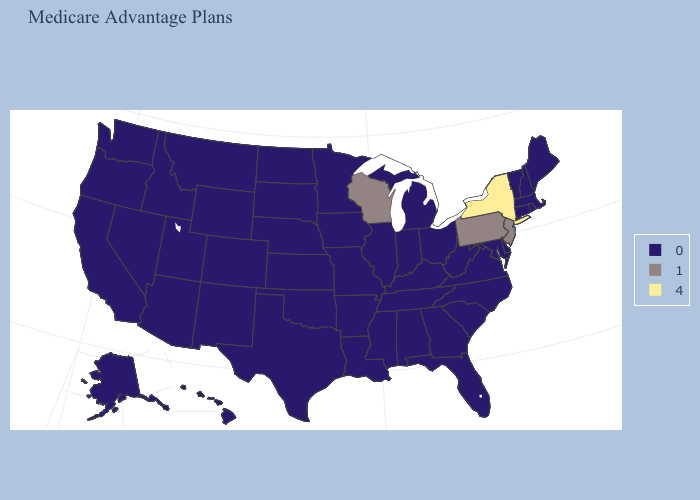What is the value of New York?
Concise answer only. 4. What is the highest value in states that border Alabama?
Answer briefly. 0. What is the value of Nebraska?
Short answer required. 0. Does Michigan have the highest value in the MidWest?
Answer briefly. No. What is the highest value in the USA?
Give a very brief answer. 4. Name the states that have a value in the range 1?
Write a very short answer. New Jersey, Pennsylvania, Wisconsin. What is the value of California?
Concise answer only. 0. Does Wisconsin have the highest value in the MidWest?
Answer briefly. Yes. Name the states that have a value in the range 0?
Short answer required. Alaska, Alabama, Arkansas, Arizona, California, Colorado, Connecticut, Delaware, Florida, Georgia, Hawaii, Iowa, Idaho, Illinois, Indiana, Kansas, Kentucky, Louisiana, Massachusetts, Maryland, Maine, Michigan, Minnesota, Missouri, Mississippi, Montana, North Carolina, North Dakota, Nebraska, New Hampshire, New Mexico, Nevada, Ohio, Oklahoma, Oregon, Rhode Island, South Carolina, South Dakota, Tennessee, Texas, Utah, Virginia, Vermont, Washington, West Virginia, Wyoming. Name the states that have a value in the range 0?
Write a very short answer. Alaska, Alabama, Arkansas, Arizona, California, Colorado, Connecticut, Delaware, Florida, Georgia, Hawaii, Iowa, Idaho, Illinois, Indiana, Kansas, Kentucky, Louisiana, Massachusetts, Maryland, Maine, Michigan, Minnesota, Missouri, Mississippi, Montana, North Carolina, North Dakota, Nebraska, New Hampshire, New Mexico, Nevada, Ohio, Oklahoma, Oregon, Rhode Island, South Carolina, South Dakota, Tennessee, Texas, Utah, Virginia, Vermont, Washington, West Virginia, Wyoming. What is the value of Delaware?
Concise answer only. 0. What is the value of California?
Quick response, please. 0. What is the value of North Carolina?
Answer briefly. 0. 